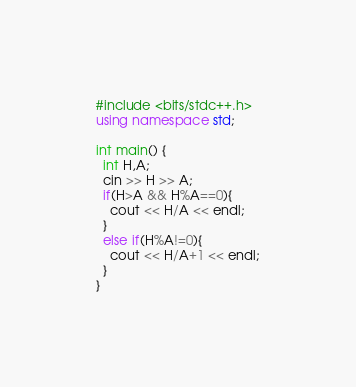<code> <loc_0><loc_0><loc_500><loc_500><_C++_>#include <bits/stdc++.h>
using namespace std;

int main() {
  int H,A;
  cin >> H >> A;
  if(H>A && H%A==0){
    cout << H/A << endl;
  }
  else if(H%A!=0){
    cout << H/A+1 << endl;
  }
}
</code> 